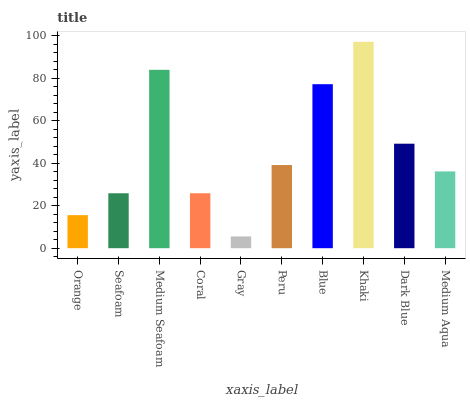Is Gray the minimum?
Answer yes or no. Yes. Is Khaki the maximum?
Answer yes or no. Yes. Is Seafoam the minimum?
Answer yes or no. No. Is Seafoam the maximum?
Answer yes or no. No. Is Seafoam greater than Orange?
Answer yes or no. Yes. Is Orange less than Seafoam?
Answer yes or no. Yes. Is Orange greater than Seafoam?
Answer yes or no. No. Is Seafoam less than Orange?
Answer yes or no. No. Is Peru the high median?
Answer yes or no. Yes. Is Medium Aqua the low median?
Answer yes or no. Yes. Is Dark Blue the high median?
Answer yes or no. No. Is Dark Blue the low median?
Answer yes or no. No. 